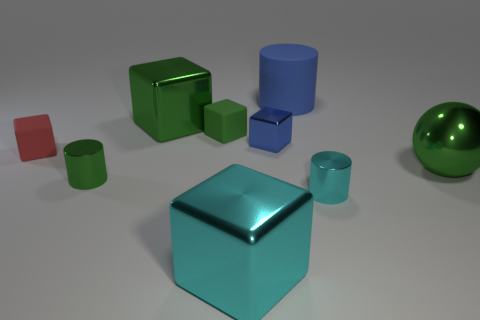What is the color of the shiny ball?
Your response must be concise. Green. There is a object that is the same color as the large cylinder; what shape is it?
Your response must be concise. Cube. Are there any green shiny things?
Provide a succinct answer. Yes. The green ball that is the same material as the tiny blue object is what size?
Provide a short and direct response. Large. What is the shape of the large metallic thing on the right side of the tiny cylinder that is right of the cube that is in front of the tiny red matte cube?
Offer a very short reply. Sphere. Is the number of cyan cylinders left of the big rubber cylinder the same as the number of tiny purple rubber blocks?
Keep it short and to the point. Yes. There is a thing that is the same color as the big cylinder; what is its size?
Provide a short and direct response. Small. Is the shape of the big blue object the same as the tiny cyan shiny thing?
Ensure brevity in your answer.  Yes. What number of things are shiny things that are to the left of the matte cylinder or tiny matte objects?
Keep it short and to the point. 6. Are there the same number of red rubber objects in front of the big ball and blue metal things that are behind the big cylinder?
Ensure brevity in your answer.  Yes. 